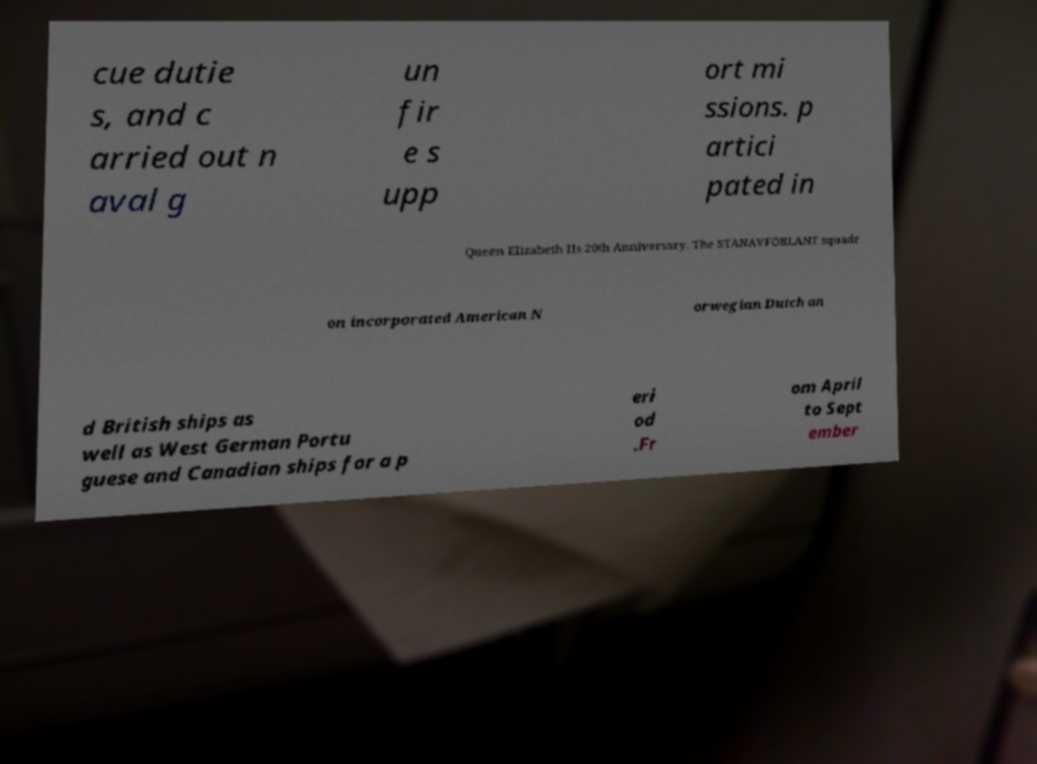There's text embedded in this image that I need extracted. Can you transcribe it verbatim? cue dutie s, and c arried out n aval g un fir e s upp ort mi ssions. p artici pated in Queen Elizabeth IIs 20th Anniversary. The STANAVFORLANT squadr on incorporated American N orwegian Dutch an d British ships as well as West German Portu guese and Canadian ships for a p eri od .Fr om April to Sept ember 